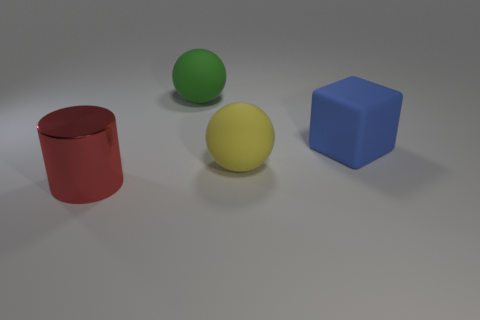Subtract all green spheres. How many spheres are left? 1 Add 1 blue cubes. How many objects exist? 5 Subtract 1 blocks. How many blocks are left? 0 Subtract all cubes. How many objects are left? 3 Subtract all blue cylinders. Subtract all blue cubes. How many cylinders are left? 1 Subtract all cyan cylinders. How many purple cubes are left? 0 Subtract all big blue rubber blocks. Subtract all purple shiny cylinders. How many objects are left? 3 Add 1 balls. How many balls are left? 3 Add 3 small brown spheres. How many small brown spheres exist? 3 Subtract 0 cyan blocks. How many objects are left? 4 